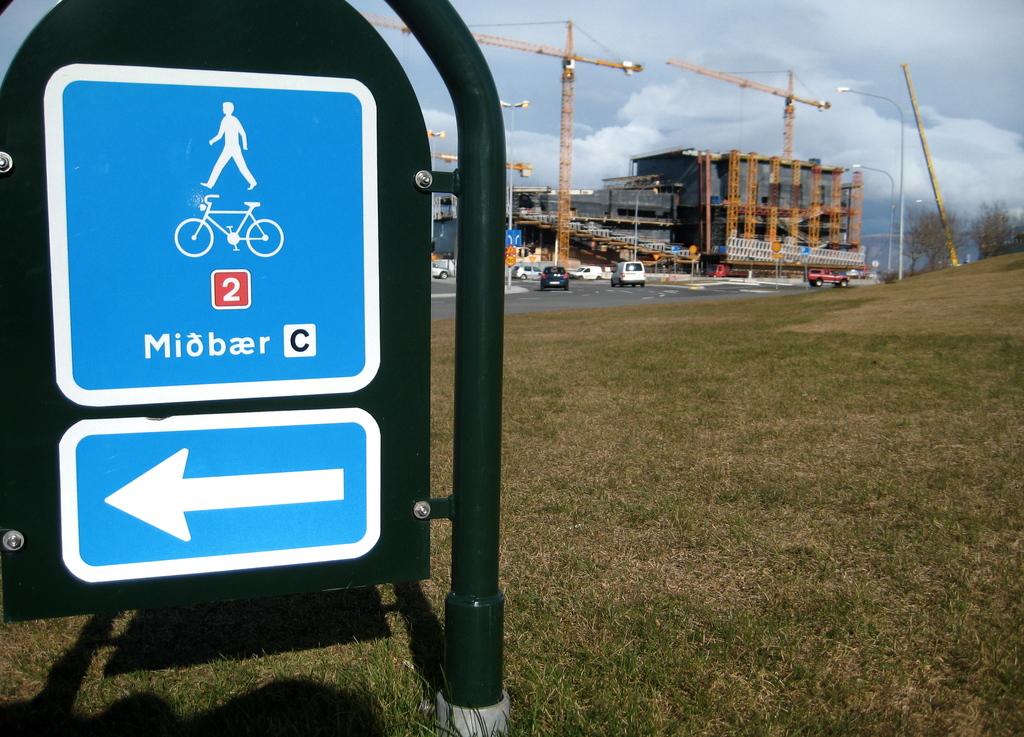What does that sign say?
Ensure brevity in your answer.  Miobaer. Left side move?
Your answer should be very brief. Yes. 